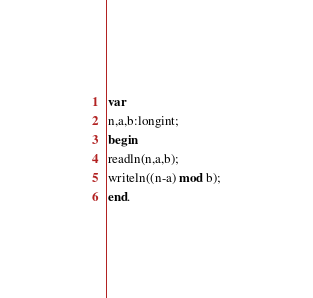Convert code to text. <code><loc_0><loc_0><loc_500><loc_500><_Pascal_>var
n,a,b:longint;
begin
readln(n,a,b);
writeln((n-a) mod b);
end.</code> 